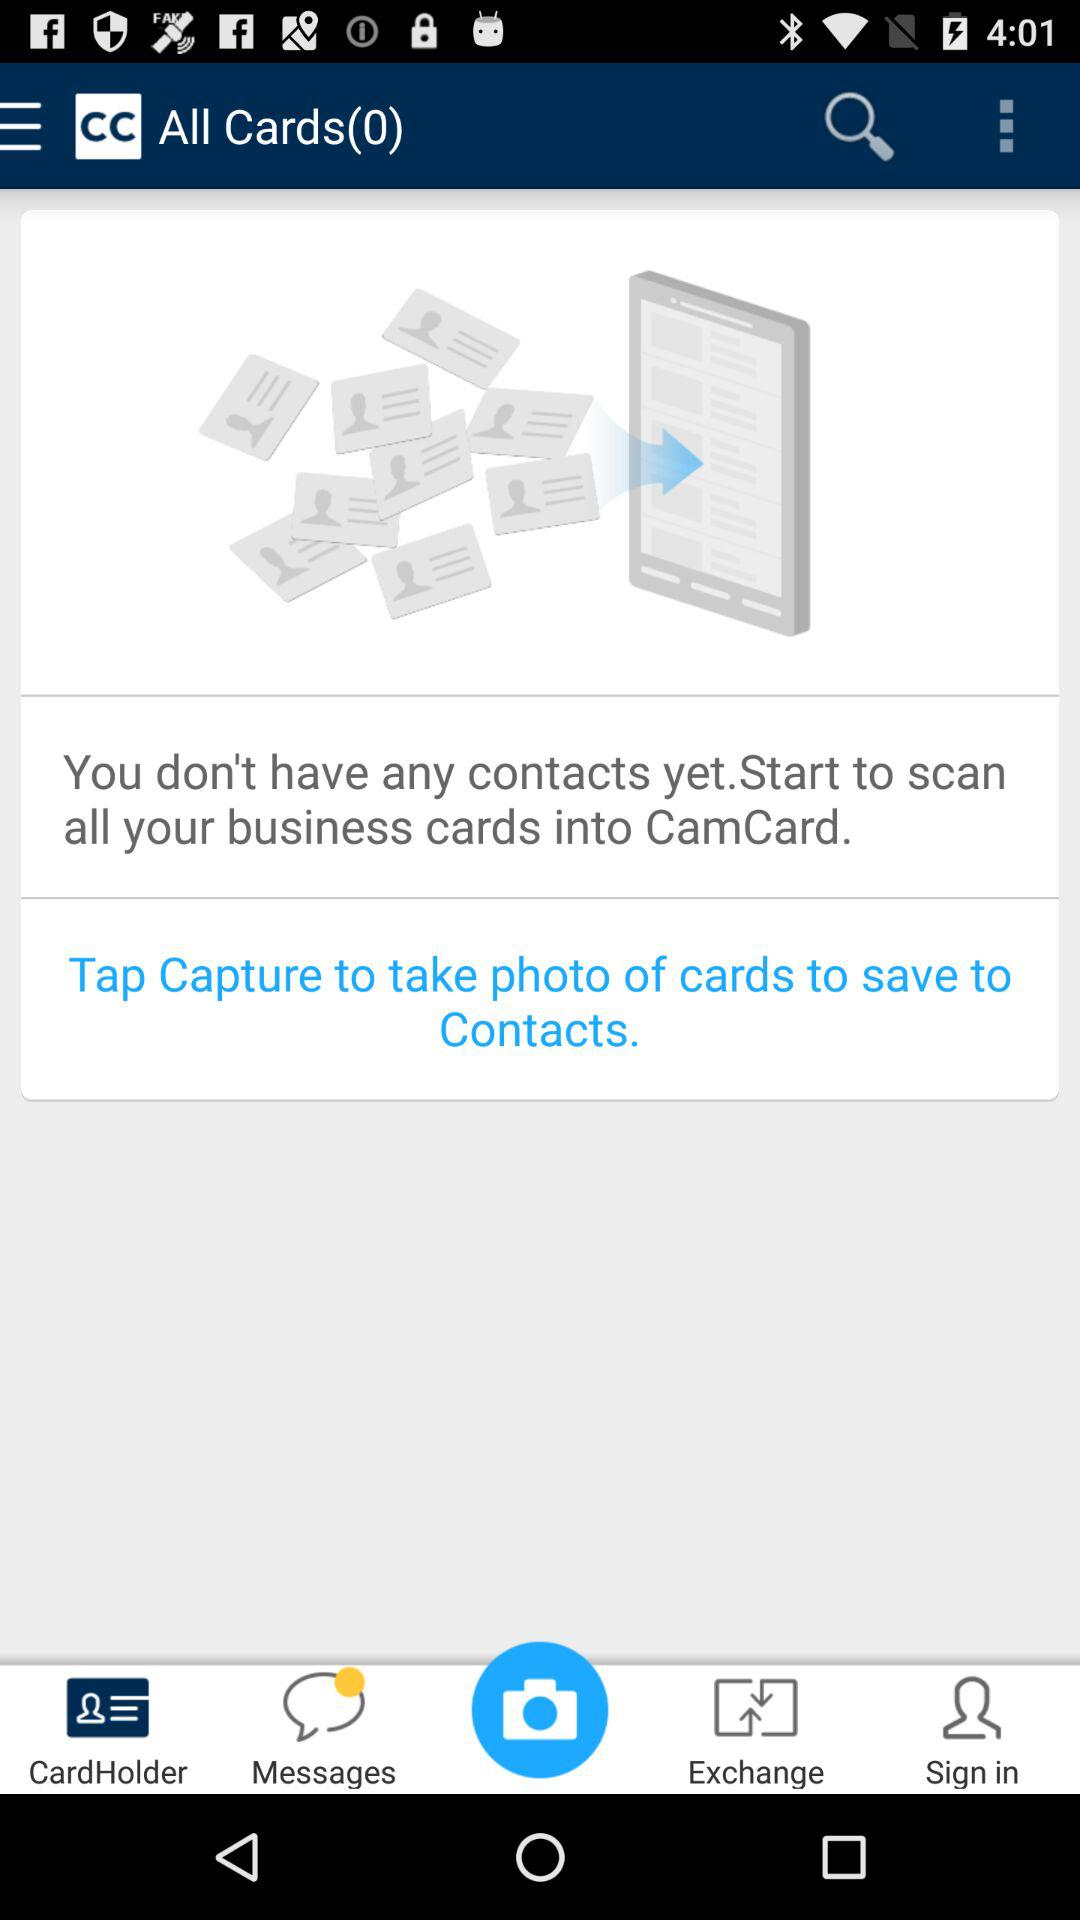Are there any contacts yet? You don't have any contacts yet. 